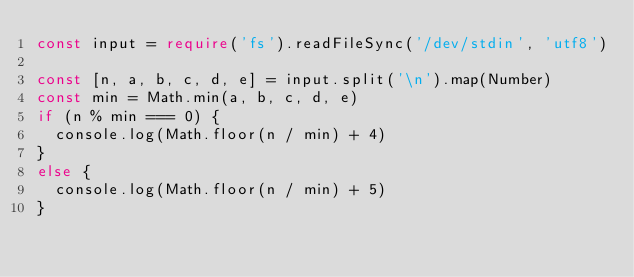Convert code to text. <code><loc_0><loc_0><loc_500><loc_500><_TypeScript_>const input = require('fs').readFileSync('/dev/stdin', 'utf8')

const [n, a, b, c, d, e] = input.split('\n').map(Number)
const min = Math.min(a, b, c, d, e)
if (n % min === 0) {
  console.log(Math.floor(n / min) + 4)
}
else {
  console.log(Math.floor(n / min) + 5)
}</code> 